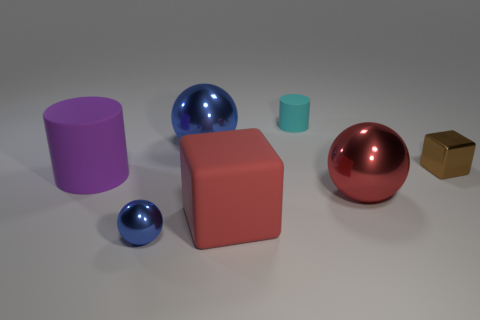Subtract all gray blocks. Subtract all blue balls. How many blocks are left? 2 Add 2 matte blocks. How many objects exist? 9 Subtract all spheres. How many objects are left? 4 Add 4 tiny matte cylinders. How many tiny matte cylinders exist? 5 Subtract 0 blue cylinders. How many objects are left? 7 Subtract all big purple cylinders. Subtract all large red shiny balls. How many objects are left? 5 Add 6 large red rubber cubes. How many large red rubber cubes are left? 7 